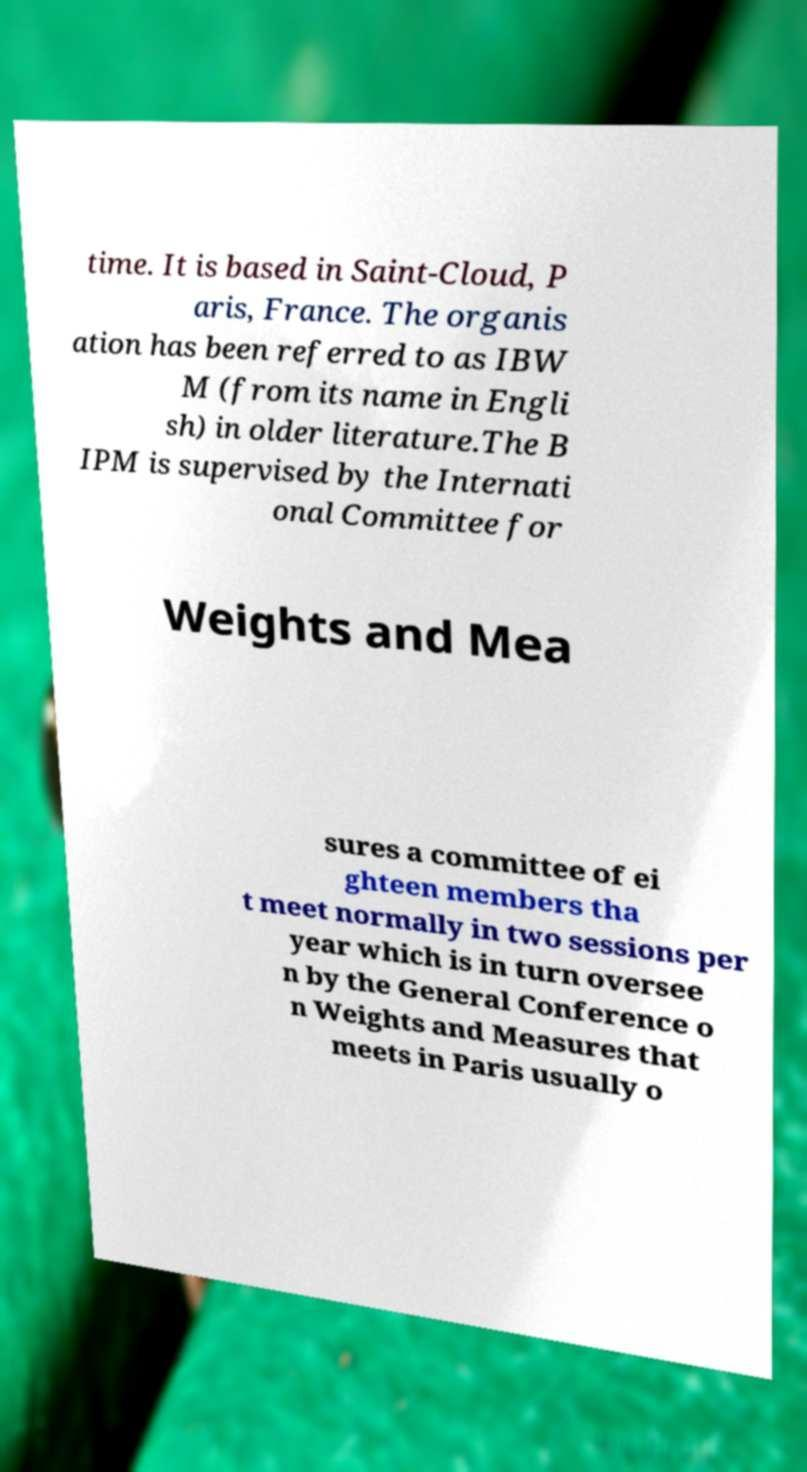What messages or text are displayed in this image? I need them in a readable, typed format. time. It is based in Saint-Cloud, P aris, France. The organis ation has been referred to as IBW M (from its name in Engli sh) in older literature.The B IPM is supervised by the Internati onal Committee for Weights and Mea sures a committee of ei ghteen members tha t meet normally in two sessions per year which is in turn oversee n by the General Conference o n Weights and Measures that meets in Paris usually o 